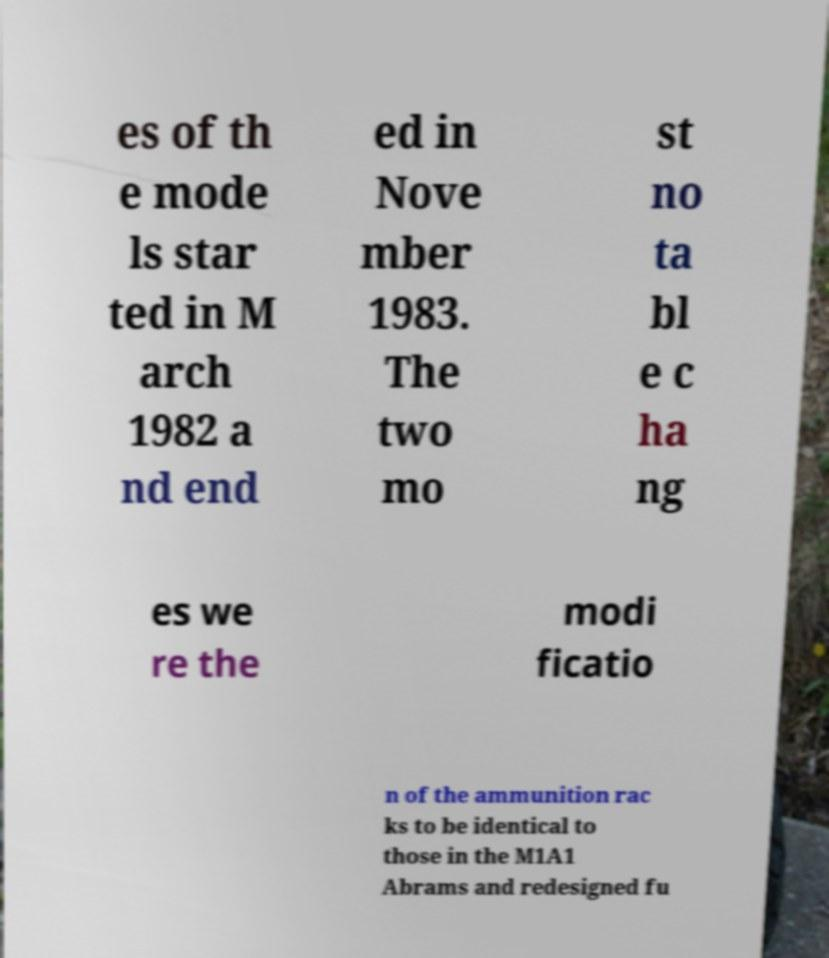Can you accurately transcribe the text from the provided image for me? es of th e mode ls star ted in M arch 1982 a nd end ed in Nove mber 1983. The two mo st no ta bl e c ha ng es we re the modi ficatio n of the ammunition rac ks to be identical to those in the M1A1 Abrams and redesigned fu 